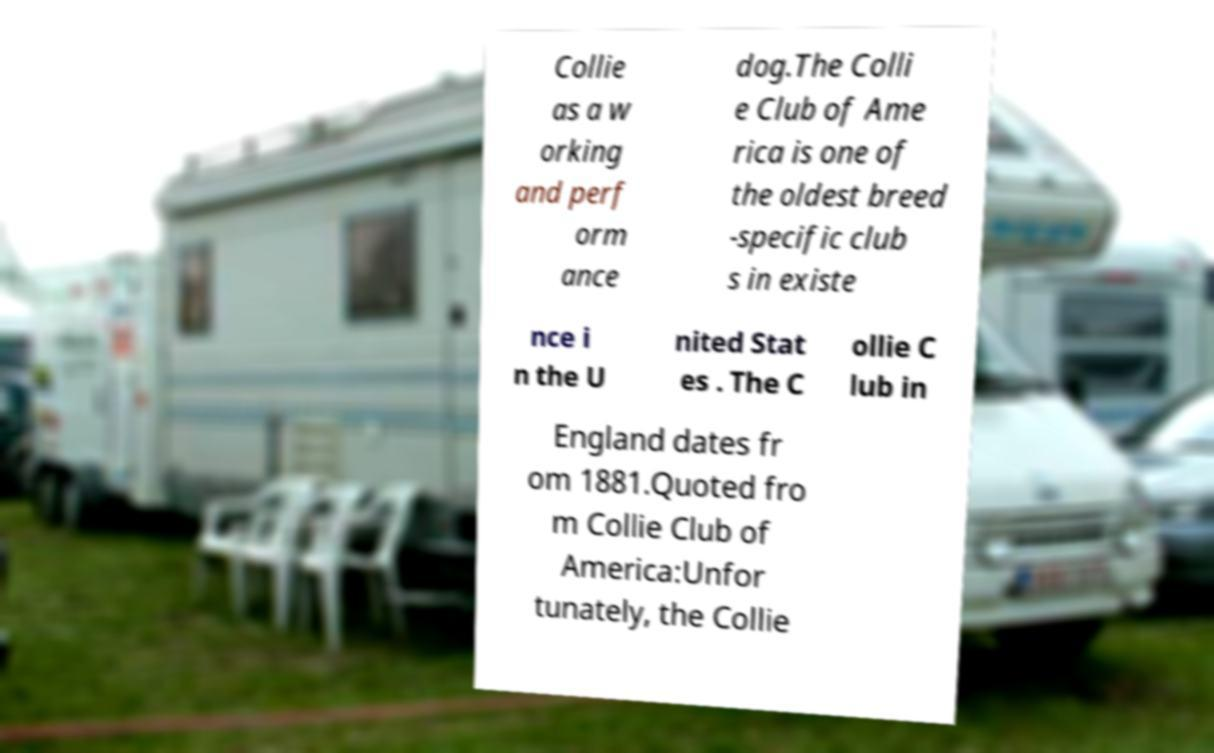I need the written content from this picture converted into text. Can you do that? Collie as a w orking and perf orm ance dog.The Colli e Club of Ame rica is one of the oldest breed -specific club s in existe nce i n the U nited Stat es . The C ollie C lub in England dates fr om 1881.Quoted fro m Collie Club of America:Unfor tunately, the Collie 